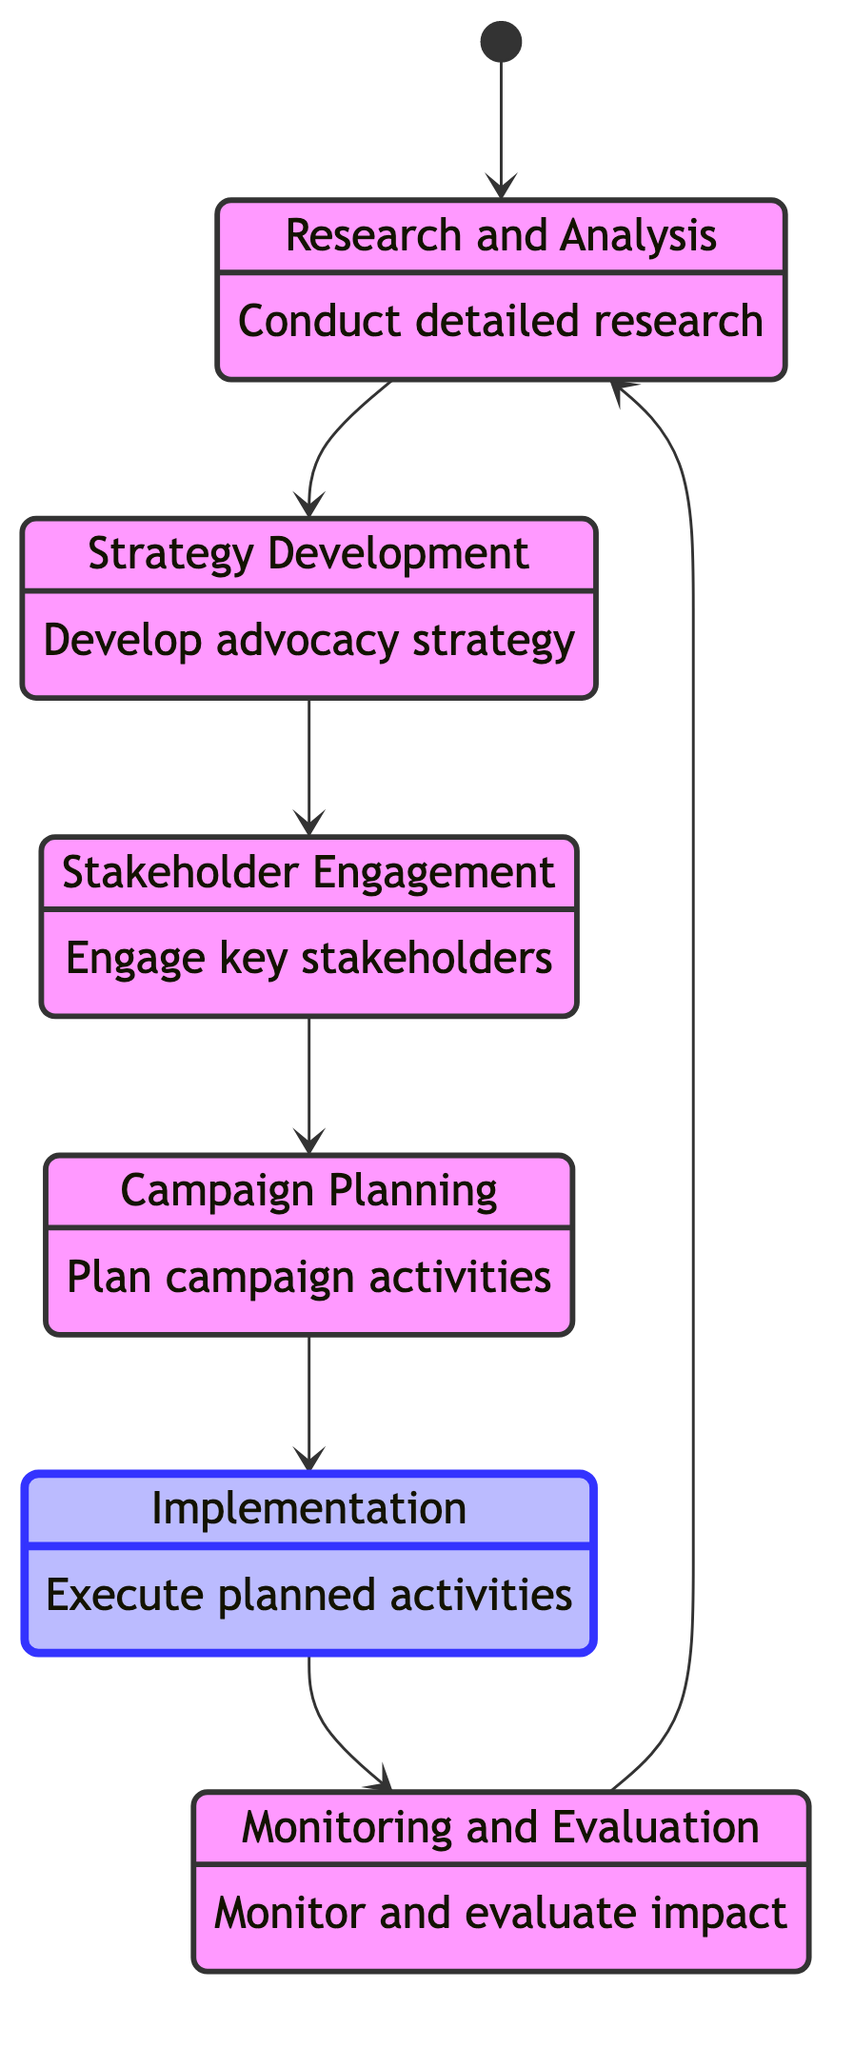What is the initial state of the campaign? The initial state, as indicated by the diagram, starts with the transition from the starting point to "Research and Analysis."
Answer: Research and Analysis How many states are in the diagram? By counting each unique state listed in the diagram, we find there are six states represented.
Answer: 6 Which state comes after "Stakeholder Engagement"? The transition from "Stakeholder Engagement" leads directly to "Campaign Planning," indicating this next step in the sequence.
Answer: Campaign Planning What is the last phase before "Research and Analysis"? The diagram shows that "Monitoring and Evaluation" transitions back into "Research and Analysis," making it the last phase before reverting to the first.
Answer: Monitoring and Evaluation What is the primary activity in the "Implementation" phase? The key activity described in the "Implementation" state includes executing planned activities such as lobbying and public outreach.
Answer: Execute planned activities Which state involves developing a comprehensive advocacy strategy? Within the diagram, "Strategy Development" is identified as the state focused on formulating a comprehensive approach to advocacy.
Answer: Strategy Development How does "Campaign Planning" relate to "Implementation"? The flow of the diagram indicates a direct transition from "Campaign Planning" to "Implementation," showing their sequential relationship.
Answer: Direct transition What state is classified as active in the diagram? The diagram indicates that "Implementation" is marked as the active state, highlighting its current focus and importance in the campaign process.
Answer: Implementation In which state do you identify and engage key stakeholders? The "Stakeholder Engagement" phase specifically outlines the action of identifying and engaging essential stakeholders in the campaign.
Answer: Stakeholder Engagement 